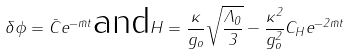<formula> <loc_0><loc_0><loc_500><loc_500>\delta \phi = \bar { C } e ^ { - \bar { m } t } \text {and} H = \frac { \kappa } { g _ { o } } \sqrt { \frac { \Lambda _ { 0 } } { 3 } } - \frac { \kappa ^ { 2 } } { g _ { o } ^ { 2 } } C _ { H } e ^ { - 2 \bar { m } t }</formula> 